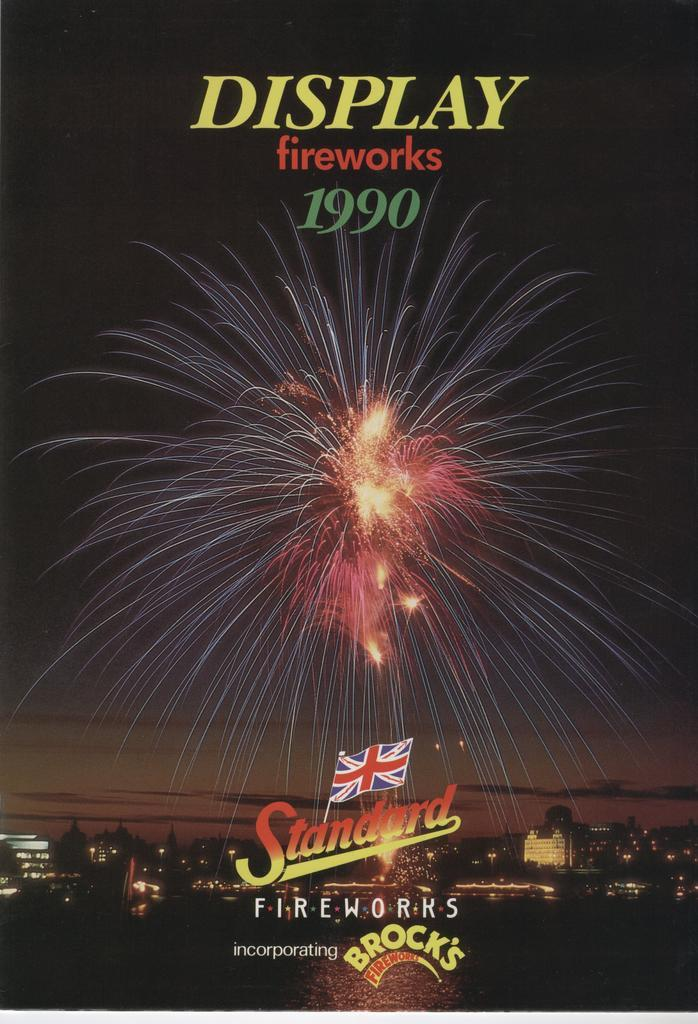Provide a one-sentence caption for the provided image. A poster advertises a fireworks show that took place in 1990. 